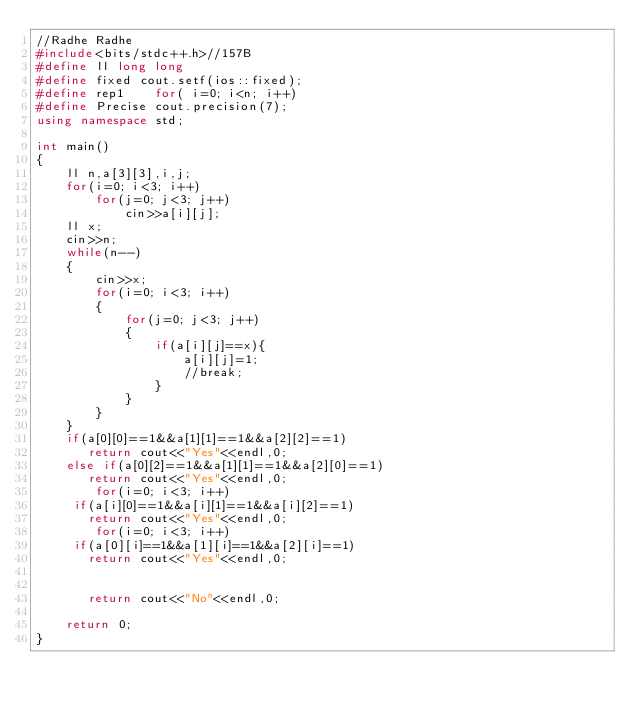<code> <loc_0><loc_0><loc_500><loc_500><_C++_>//Radhe Radhe
#include<bits/stdc++.h>//157B
#define ll long long
#define fixed cout.setf(ios::fixed);
#define rep1    for( i=0; i<n; i++)
#define Precise cout.precision(7);
using namespace std;

int main()
{
    ll n,a[3][3],i,j;
    for(i=0; i<3; i++)
        for(j=0; j<3; j++)
            cin>>a[i][j];
    ll x;
    cin>>n;
    while(n--)
    {
        cin>>x;
        for(i=0; i<3; i++)
        {
            for(j=0; j<3; j++)
            {
                if(a[i][j]==x){
                    a[i][j]=1;
                    //break;
                }
            }
        }
    }
    if(a[0][0]==1&&a[1][1]==1&&a[2][2]==1)
       return cout<<"Yes"<<endl,0;
    else if(a[0][2]==1&&a[1][1]==1&&a[2][0]==1)
       return cout<<"Yes"<<endl,0;
        for(i=0; i<3; i++)
     if(a[i][0]==1&&a[i][1]==1&&a[i][2]==1)
       return cout<<"Yes"<<endl,0;
        for(i=0; i<3; i++)
     if(a[0][i]==1&&a[1][i]==1&&a[2][i]==1)
       return cout<<"Yes"<<endl,0;


       return cout<<"No"<<endl,0;

    return 0;
}



</code> 